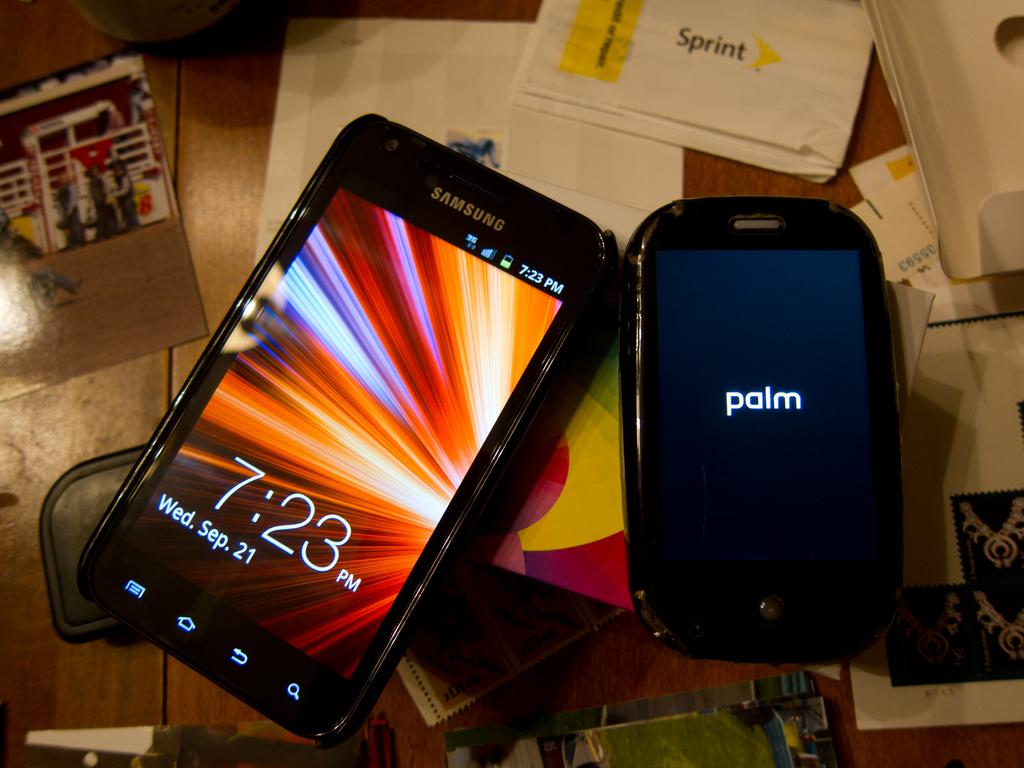<image>
Describe the image concisely. Two phones with the one on the right having the word "palm" on it. 